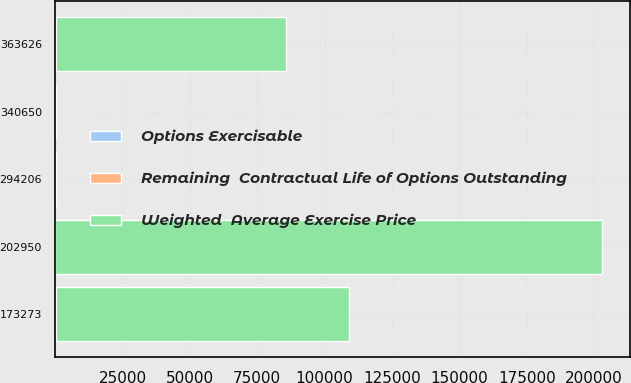<chart> <loc_0><loc_0><loc_500><loc_500><stacked_bar_chart><ecel><fcel>294206<fcel>202950<fcel>340650<fcel>173273<fcel>363626<nl><fcel>Remaining  Contractual Life of Options Outstanding<fcel>84.18<fcel>109<fcel>141.5<fcel>169.37<fcel>271.34<nl><fcel>Options Exercisable<fcel>3.4<fcel>1.9<fcel>5.3<fcel>6.8<fcel>8.8<nl><fcel>Weighted  Average Exercise Price<fcel>109<fcel>202950<fcel>109<fcel>109023<fcel>85335<nl></chart> 